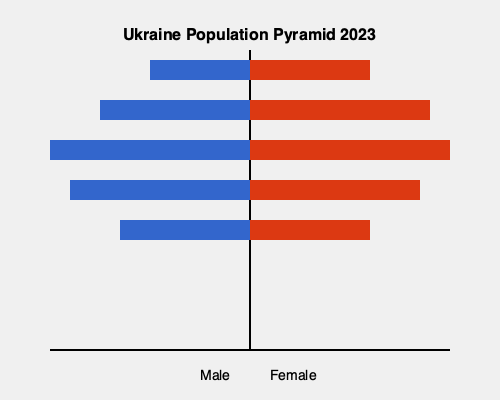Based on the population pyramid for Ukraine in 2023, what are the two most significant demographic challenges facing the country's healthcare system, and how might these challenges impact healthcare policy decisions? To answer this question, we need to analyze the population pyramid and consider its implications for Ukraine's healthcare system:

1. Aging population:
   - The pyramid shows a large proportion of the population in the 40-59 and 60-79 age groups.
   - This indicates an aging population, which will lead to increased demand for healthcare services related to age-related conditions such as cardiovascular diseases, cancer, and dementia.

2. Gender imbalance in older age groups:
   - There is a noticeable difference between the male and female populations in the 60-79 and 80+ age groups, with more females than males.
   - This suggests a higher life expectancy for women, which may require targeted healthcare policies for elderly women.

3. Shrinking working-age population:
   - The 20-39 age group is smaller than the 40-59 age group, indicating a potential decrease in the working-age population.
   - This could lead to reduced tax revenue and strain on the healthcare system's funding.

4. Low birth rates:
   - The 0-19 age group is smaller than the older age groups, suggesting low birth rates.
   - This could lead to a further aging of the population in the future, exacerbating the challenges associated with an aging population.

Given these observations, the two most significant demographic challenges are:

1. An aging population, which will increase the demand for healthcare services related to age-related conditions and long-term care.
2. A shrinking working-age population, which may lead to reduced funding for the healthcare system.

These challenges may impact healthcare policy decisions in the following ways:

- Increased focus on geriatric care and age-related disease prevention and management.
- Development of home-care and community-based services to support the elderly population.
- Initiatives to improve healthcare efficiency and cost-effectiveness to manage the increased demand with potentially reduced resources.
- Policies to attract and retain healthcare workers, particularly those specializing in geriatric care.
- Emphasis on preventive care and health promotion to reduce the burden of chronic diseases in the aging population.
- Consideration of innovative funding mechanisms to ensure the sustainability of the healthcare system in the face of a shrinking working-age population.
Answer: Aging population and shrinking working-age population, leading to increased healthcare demand and potential funding challenges. 